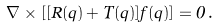Convert formula to latex. <formula><loc_0><loc_0><loc_500><loc_500>\nabla \times [ [ R ( { q } ) + T ( { q } ) ] { f } ( { q } ) ] = 0 \, .</formula> 